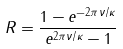Convert formula to latex. <formula><loc_0><loc_0><loc_500><loc_500>R = \frac { 1 - e ^ { - 2 \pi \nu / \kappa } } { e ^ { 2 \pi \nu / \kappa } - 1 }</formula> 